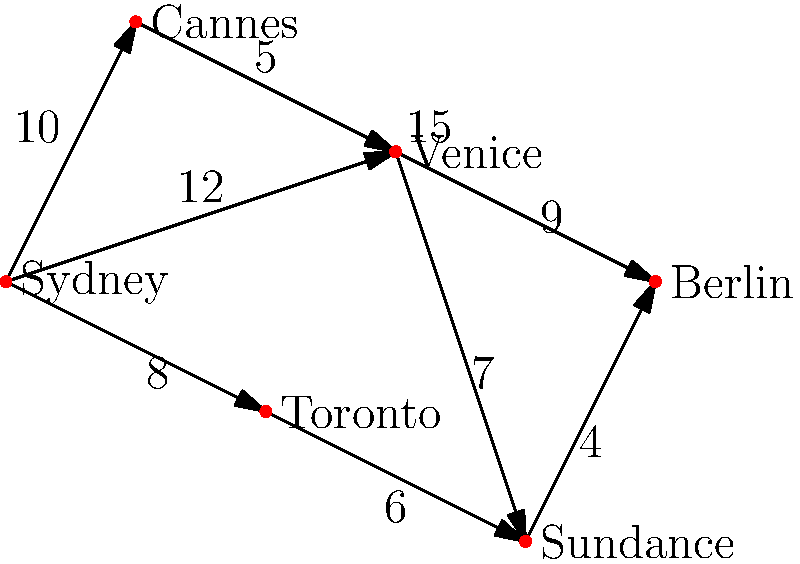As an aspiring film critic planning to attend international film festivals, you want to find the shortest path from Sydney to Berlin while visiting as many major festivals as possible. Each edge in the graph represents a direct flight between two festival locations, with the number indicating the flight duration in hours. What is the shortest total travel time from Sydney to Berlin, visiting at least three other festivals along the way? To solve this problem, we'll use Dijkstra's algorithm to find the shortest path from Sydney to Berlin while visiting at least three other festivals. Here's the step-by-step process:

1. Identify all possible paths from Sydney to Berlin that visit at least three other festivals:
   a) Sydney → Cannes → Venice → Berlin
   b) Sydney → Cannes → Venice → Sundance → Berlin
   c) Sydney → Venice → Sundance → Berlin
   d) Sydney → Toronto → Sundance → Berlin

2. Calculate the total travel time for each path:
   a) Sydney → Cannes → Venice → Berlin
      $10 + 5 + 9 = 24$ hours
   
   b) Sydney → Cannes → Venice → Sundance → Berlin
      $10 + 5 + 7 + 4 = 26$ hours
   
   c) Sydney → Venice → Sundance → Berlin
      $12 + 7 + 4 = 23$ hours
   
   d) Sydney → Toronto → Sundance → Berlin
      $8 + 6 + 4 = 18$ hours

3. Compare the total travel times:
   Path (a): 24 hours
   Path (b): 26 hours
   Path (c): 23 hours
   Path (d): 18 hours

4. Identify the shortest path:
   The shortest path is (d) Sydney → Toronto → Sundance → Berlin, with a total travel time of 18 hours.

This path allows you to visit three major film festivals (Sydney, Toronto, and Sundance) before reaching your final destination in Berlin, while minimizing the total travel time.
Answer: 18 hours 